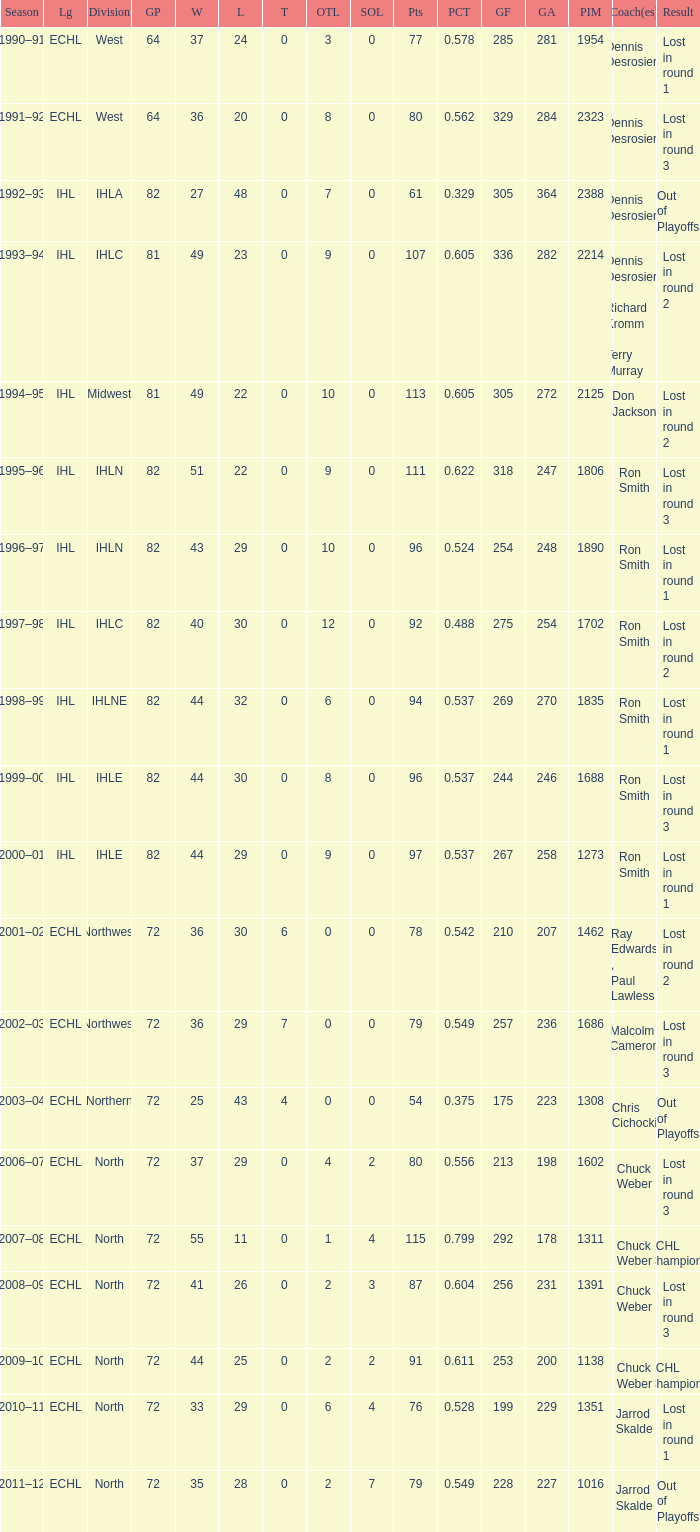What was the highest SOL where the team lost in round 3? 3.0. 